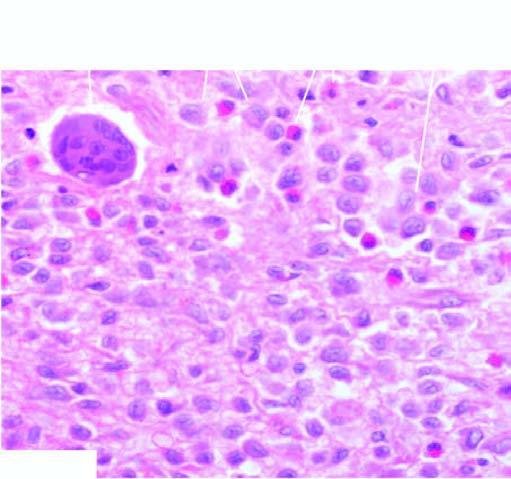did collections of histiocytes have vesicular nuclei admixed with eosinophils?
Answer the question using a single word or phrase. Yes 